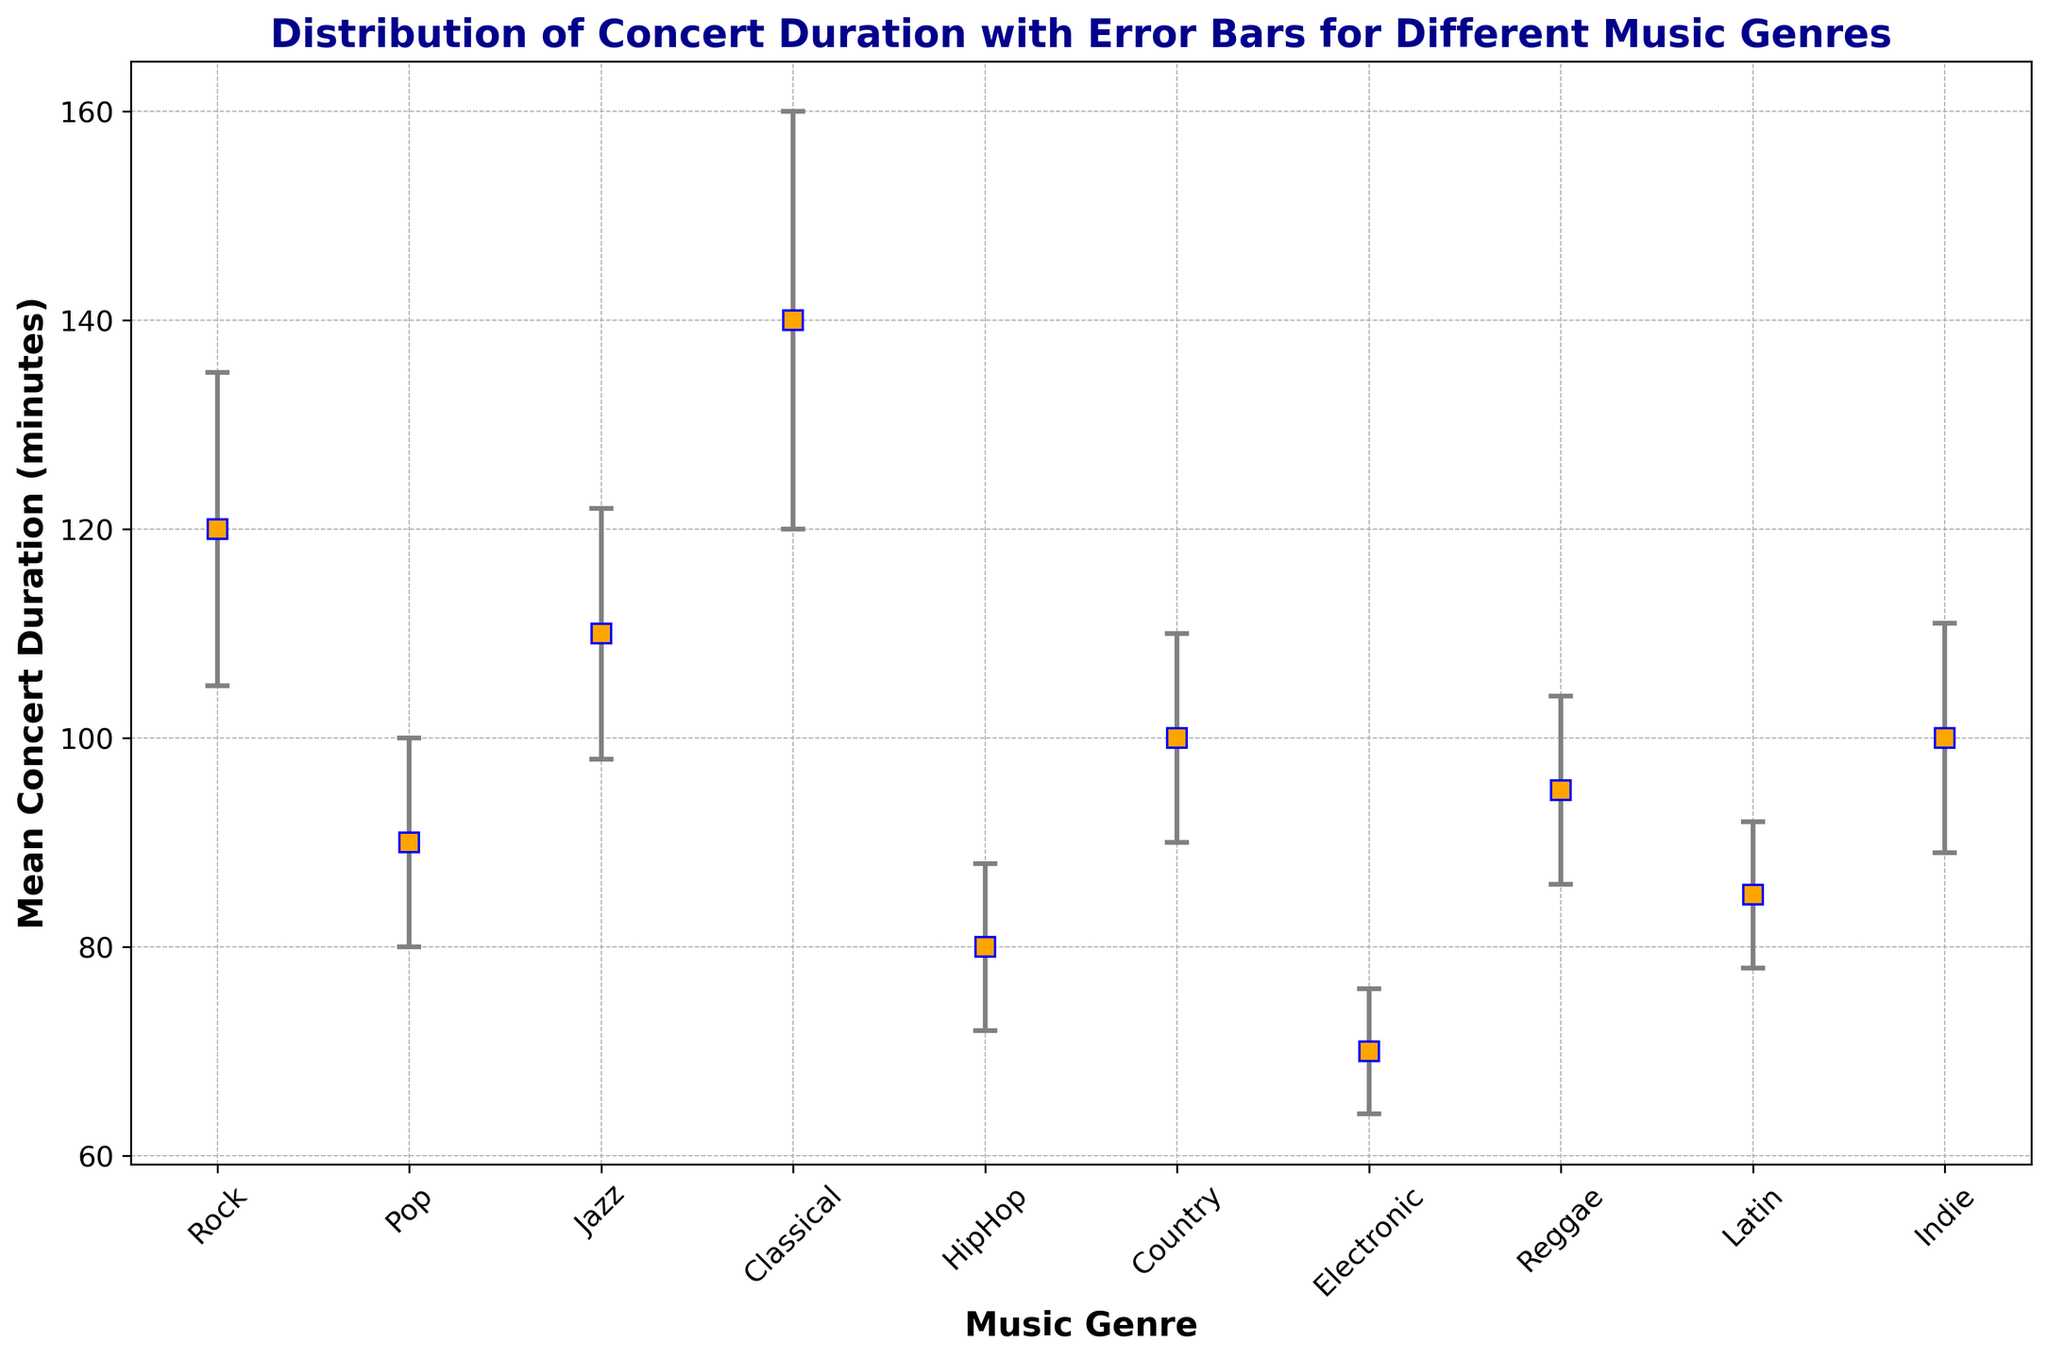What's the music genre with the longest mean concert duration? The genre with the longest mean concert duration is found by identifying the highest value on the y-axis (mean duration) and then checking the corresponding genre on the x-axis. In this case, the Classical genre has the longest mean concert duration.
Answer: Classical What is the difference in mean concert duration between Rock and Pop genres? To find the difference, subtract the mean duration of the Pop genre from the mean duration of the Rock genre. Rock has a mean duration of 120 minutes, and Pop has a mean duration of 90 minutes. So, 120 - 90 = 30 minutes.
Answer: 30 minutes Which genre has the smallest error bar? The genre with the smallest error bar is found by identifying the shortest error line around the mean duration points. Electronic has the smallest error bar, with a standard deviation of 6.
Answer: Electronic What is the average of the mean concert durations for Jazz, Classical, and Reggae genres? Calculate the average by adding the mean durations for Jazz (110), Classical (140), and Reggae (95), then divide by the number of genres (3). (110 + 140 + 95) / 3 = 345 / 3 = 115 minutes.
Answer: 115 minutes Which genre has a mean concert duration closest to 100 minutes? Visually identify the point on the y-axis nearest to 100 minutes and check the corresponding genre on the x-axis. Both Country and Indie have mean durations of 100 minutes.
Answer: Country and Indie Are there any genres with mean durations more than twice the mean duration of Electronic concerts? The mean duration of Electronic concerts is 70 minutes. To find if any genre has more than twice this duration, calculate 2 * 70 = 140 minutes. Classical is the only genre that has a mean duration of 140 minutes, exactly twice.
Answer: No What is the total of the standard deviations for HipHop and Latin genres? Sum the standard deviations of HipHop and Latin genres. HipHop has an 8-minute standard deviation, and Latin has a 7-minute standard deviation, so 8 + 7 = 15 minutes.
Answer: 15 minutes Which genre's concerts are more variable, Rock or Jazz? To assess variability, compare the length of the error bars, which represent standard deviations. Rock has a standard deviation of 15, and Jazz has a standard deviation of 12, so Rock concerts are more variable.
Answer: Rock What is the range of mean concert durations for all shown genres? To find the range, subtract the smallest mean duration from the largest mean duration. The smallest mean duration is for Electronic (70 minutes), and the largest is for Classical (140 minutes). The range is 140 - 70 = 70 minutes.
Answer: 70 minutes 